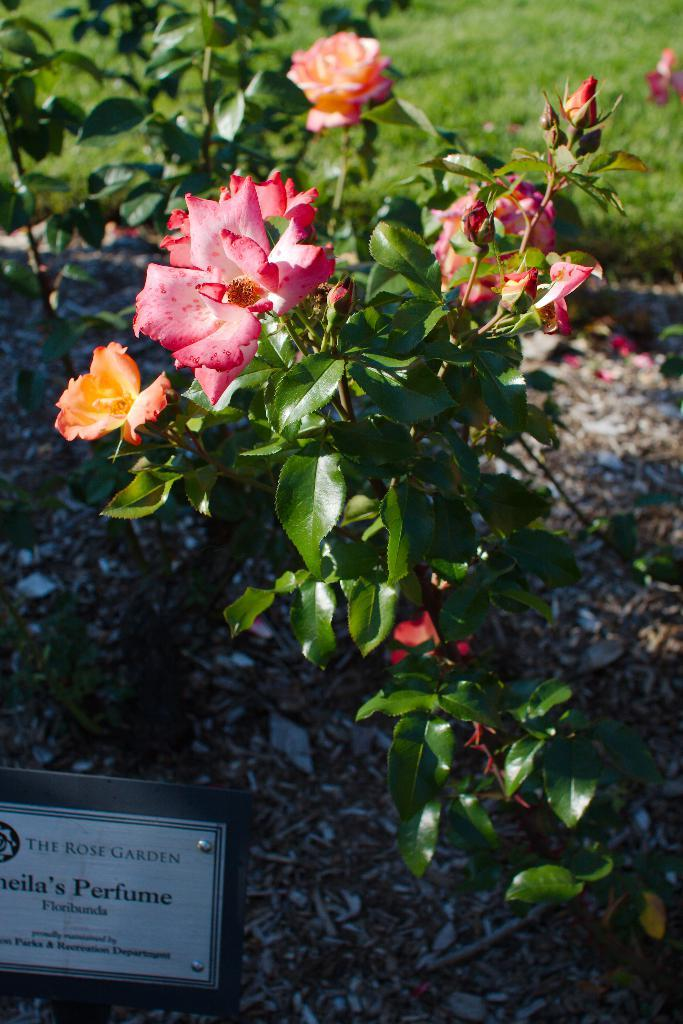What type of plants are in the image? There are rose plants in the image. What object is located in the bottom left of the image? There is a board in the bottom left of the image. What can be found on the board? There is text on the board. What type of loaf is being used to whip the match in the image? There is no loaf, whip, or match present in the image. 